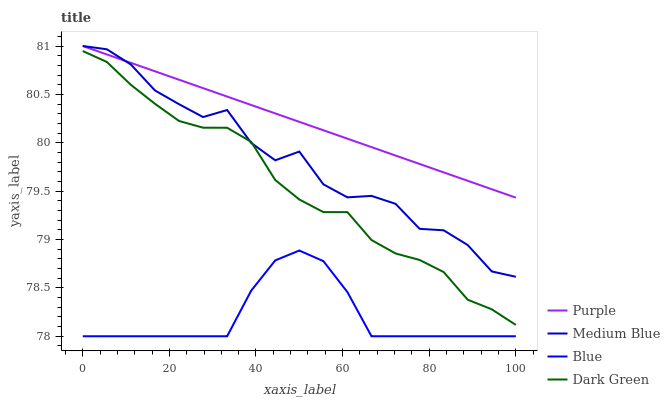Does Blue have the minimum area under the curve?
Answer yes or no. Yes. Does Purple have the maximum area under the curve?
Answer yes or no. Yes. Does Medium Blue have the minimum area under the curve?
Answer yes or no. No. Does Medium Blue have the maximum area under the curve?
Answer yes or no. No. Is Purple the smoothest?
Answer yes or no. Yes. Is Medium Blue the roughest?
Answer yes or no. Yes. Is Blue the smoothest?
Answer yes or no. No. Is Blue the roughest?
Answer yes or no. No. Does Blue have the lowest value?
Answer yes or no. Yes. Does Medium Blue have the lowest value?
Answer yes or no. No. Does Medium Blue have the highest value?
Answer yes or no. Yes. Does Blue have the highest value?
Answer yes or no. No. Is Blue less than Medium Blue?
Answer yes or no. Yes. Is Purple greater than Blue?
Answer yes or no. Yes. Does Purple intersect Medium Blue?
Answer yes or no. Yes. Is Purple less than Medium Blue?
Answer yes or no. No. Is Purple greater than Medium Blue?
Answer yes or no. No. Does Blue intersect Medium Blue?
Answer yes or no. No. 